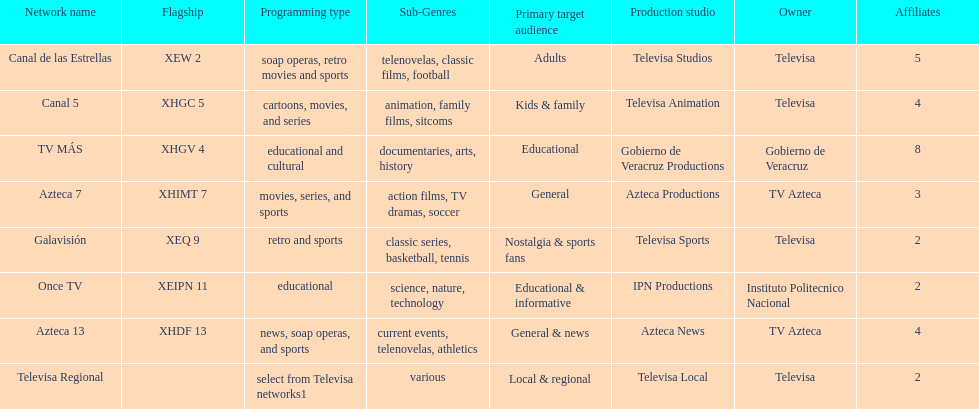Tell me the number of stations tv azteca owns. 2. 